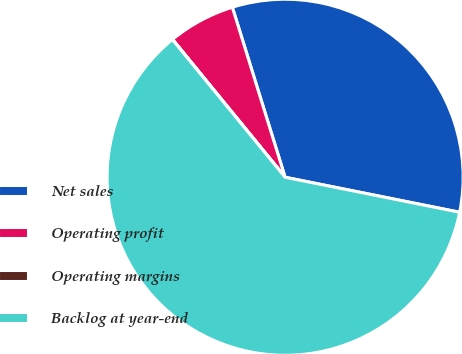Convert chart. <chart><loc_0><loc_0><loc_500><loc_500><pie_chart><fcel>Net sales<fcel>Operating profit<fcel>Operating margins<fcel>Backlog at year-end<nl><fcel>32.94%<fcel>6.11%<fcel>0.02%<fcel>60.93%<nl></chart> 